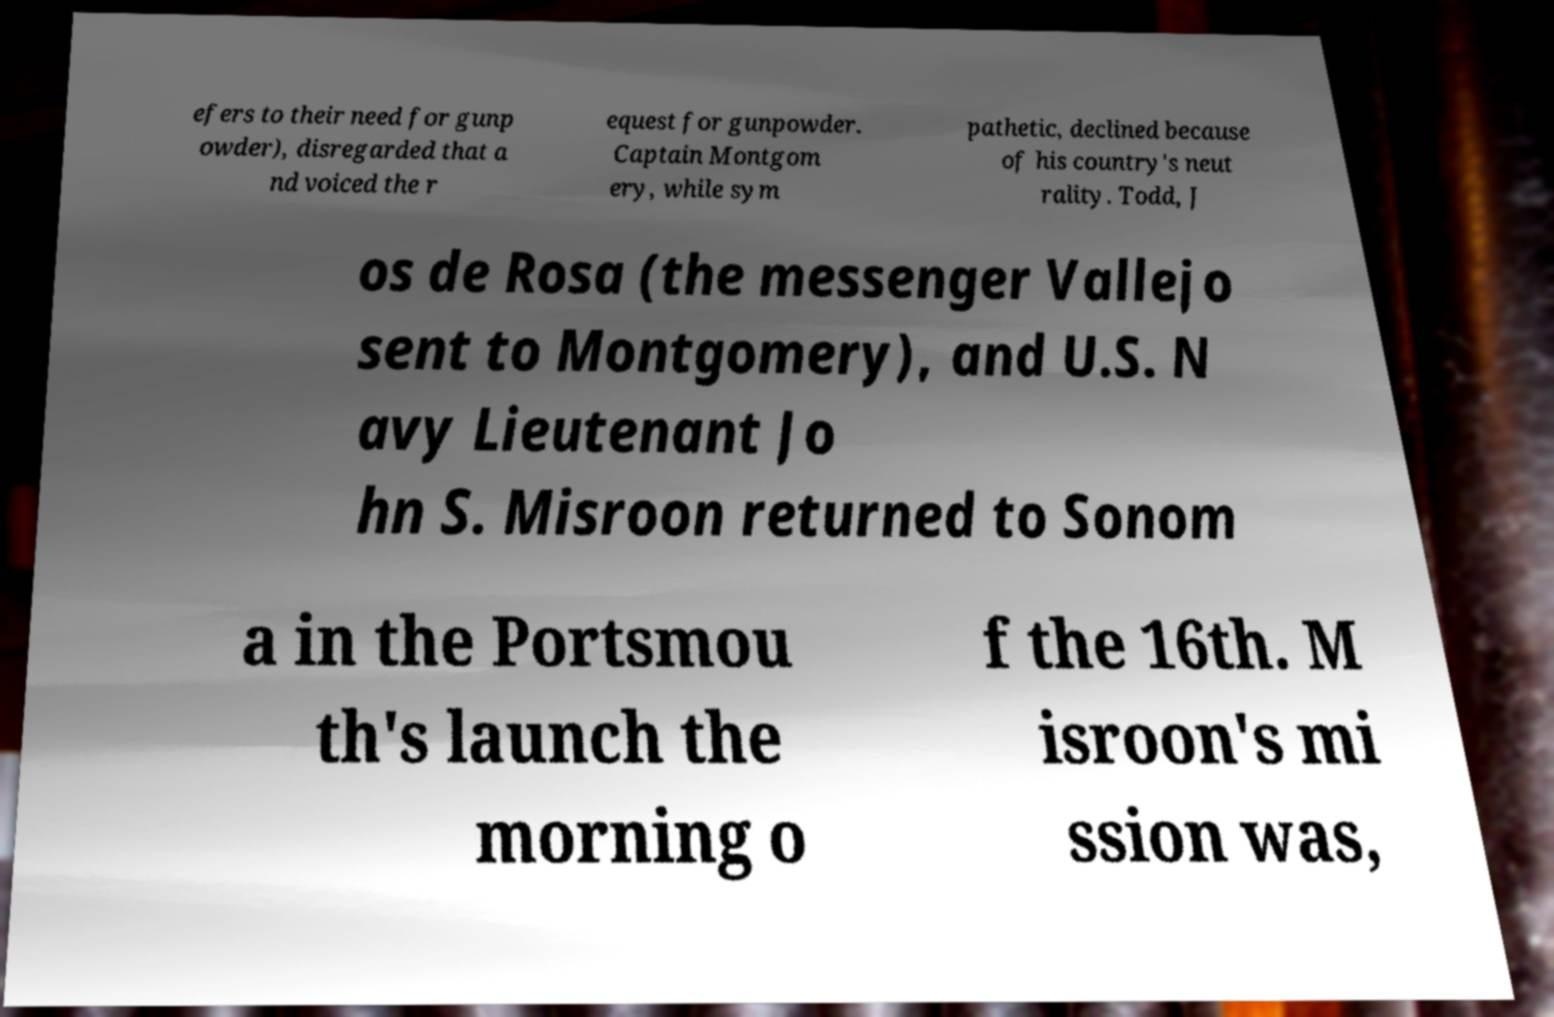Can you accurately transcribe the text from the provided image for me? efers to their need for gunp owder), disregarded that a nd voiced the r equest for gunpowder. Captain Montgom ery, while sym pathetic, declined because of his country's neut rality. Todd, J os de Rosa (the messenger Vallejo sent to Montgomery), and U.S. N avy Lieutenant Jo hn S. Misroon returned to Sonom a in the Portsmou th's launch the morning o f the 16th. M isroon's mi ssion was, 